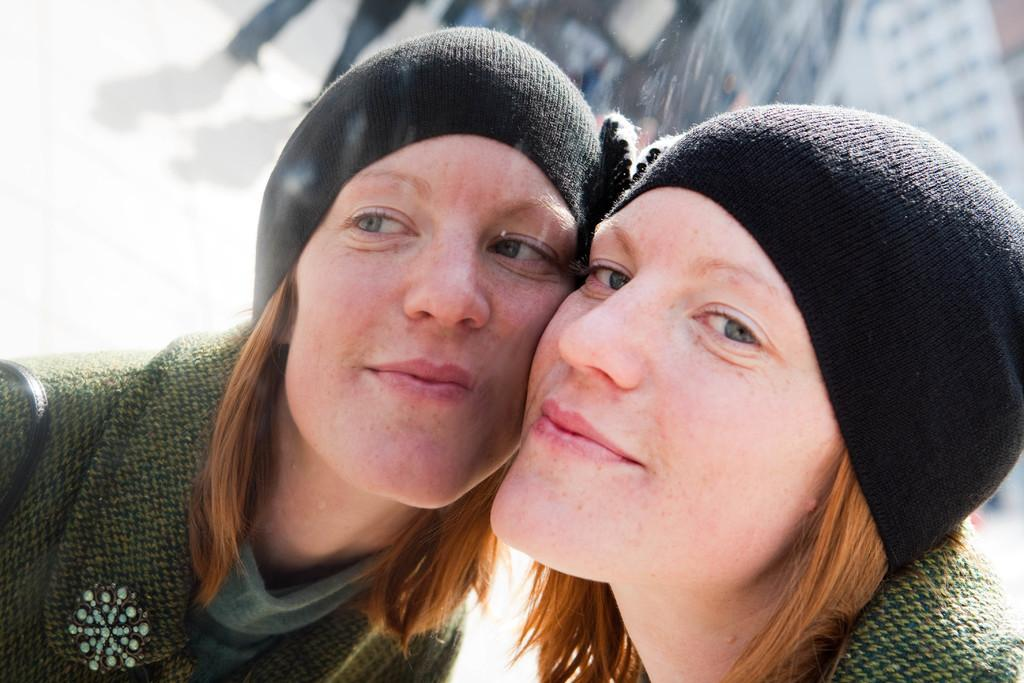How many women are in the image? There are two women in the image. What do the women have in common? The women appear to be similar to each other. What are the women wearing on their upper bodies? The women are wearing green color sweaters. What are the women wearing on their heads? The women are wearing black color caps on their heads. Can you describe the background of the image? The background of the image is blurred. What language are the women speaking in the image? There is no information about the language being spoken in the image. Can you see any stems in the image? There are no stems present in the image. 